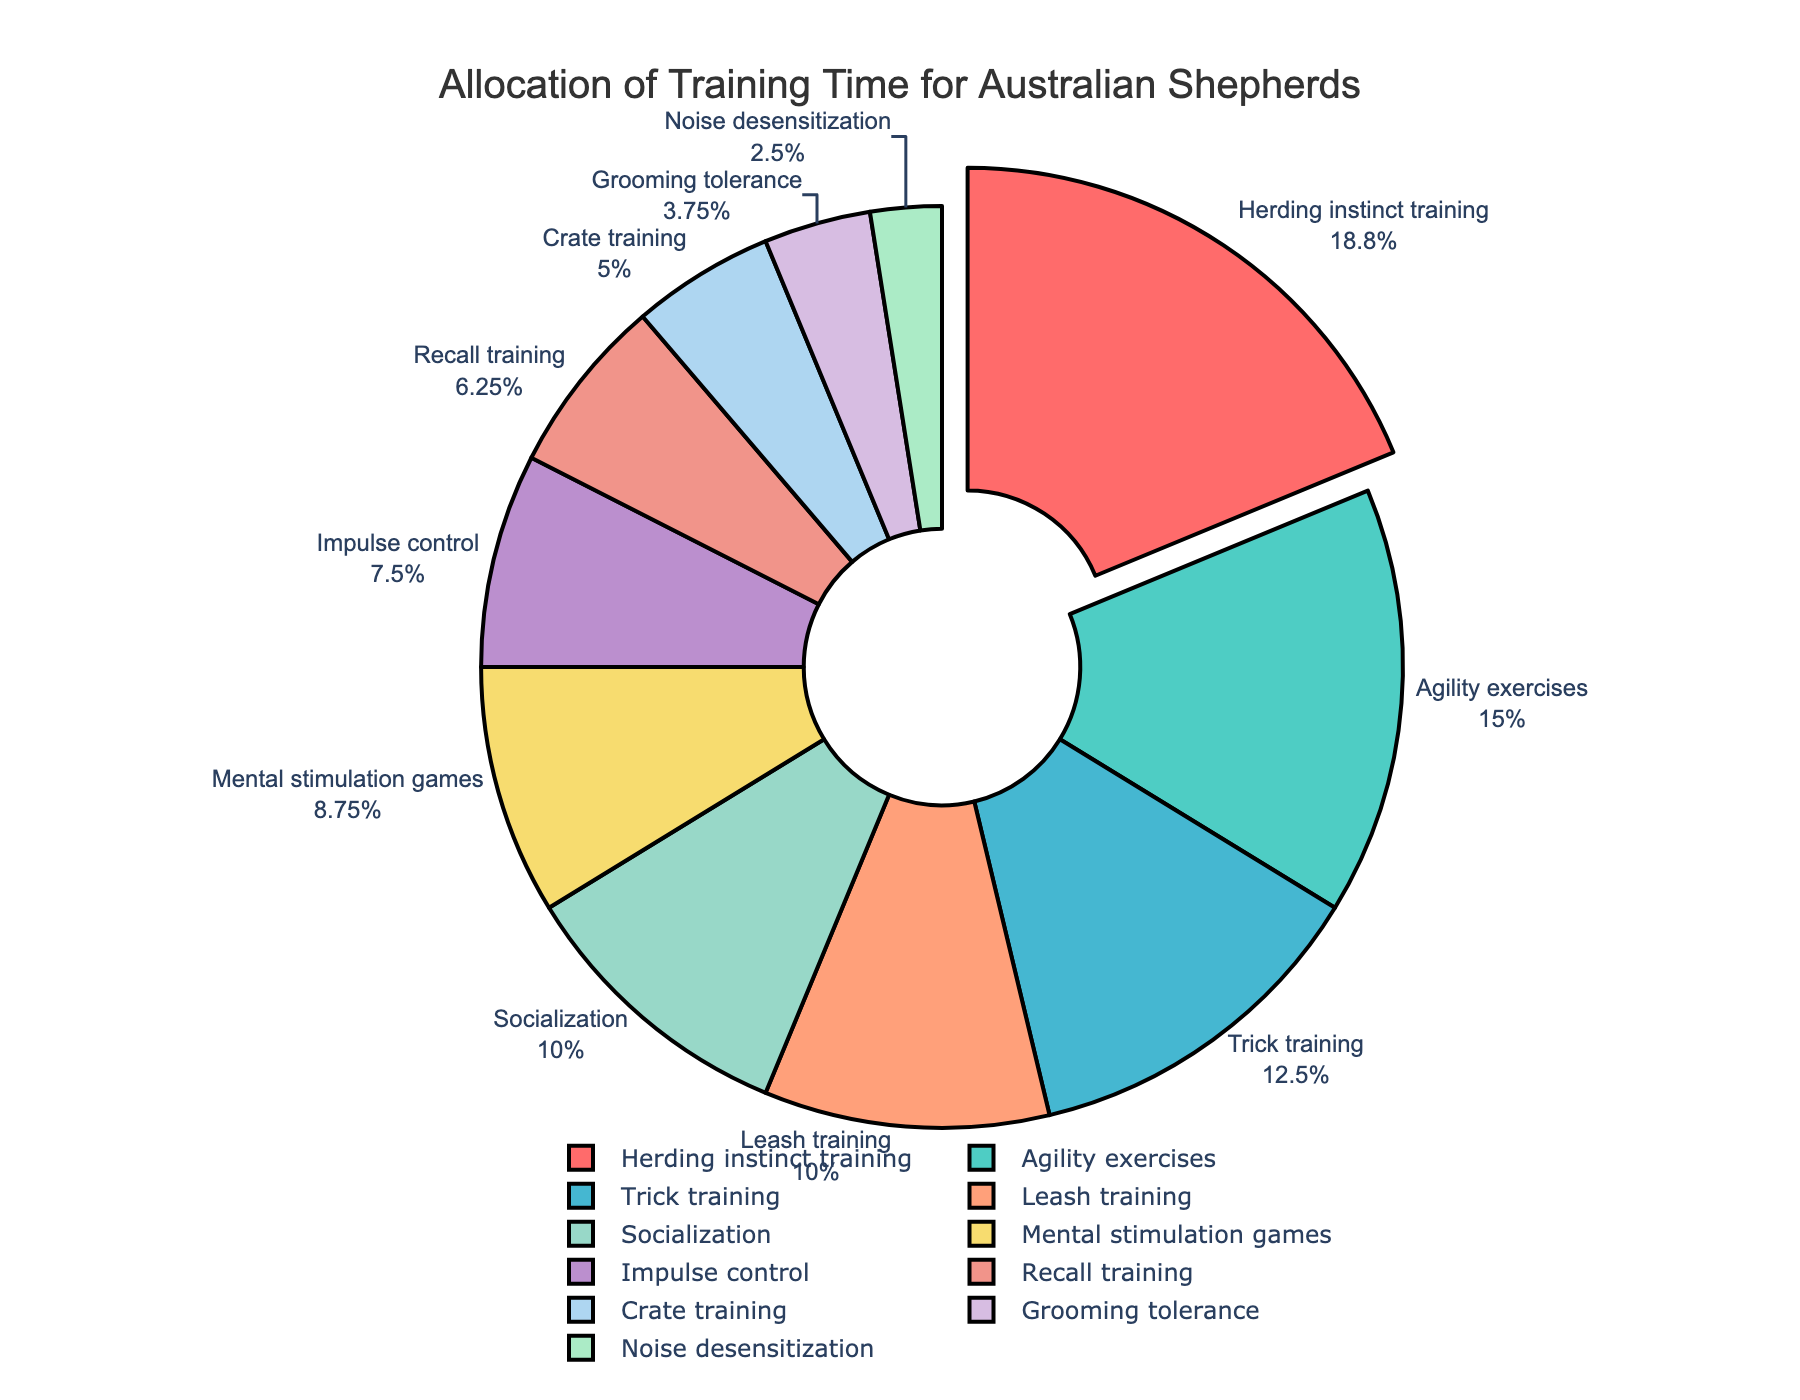What's the largest portion of the pie chart? The largest segment in the pie chart is the one pulled out from the rest, and it's labeled "Herding instinct training" with a percentage of 15%. This is the largest portion.
Answer: Herding instinct training How much time is recommended for trick training relative to leash training? Trick training accounts for 10% of the time, while leash training accounts for 8%. To find how much more time is recommended for trick training relative to leash training, subtract 8% from 10%.
Answer: 2% Which training commands/skills account for less than 5% each in the pie chart? The segments for crate training, grooming tolerance, and noise desensitization are labeled with their percentages: 4%, 3%, and 2%, respectively. All these values are less than 5%.
Answer: Crate training, Grooming tolerance, Noise desensitization What is the combined percentage for mental stimulation games and impulse control? Mental stimulation games are 7% and impulse control is 6%. Adding these together gives 7% + 6% = 13%.
Answer: 13% Which training activity is colored red? In the pie chart, the red-colored segment is "Herding instinct training," which is indicated as the largest segment and is also pulled out from the rest of the pie.
Answer: Herding instinct training Which two training activities have equal recommended times? The pie chart labels show that both leash training and socialization each account for 8% of the training time, indicating that they have equal percentages.
Answer: Leash training and Socialization What percentage of time is recommended for activities related to both physical and mental stimulation combined? Activities related to physical stimulation are herding instinct training (15%) and agility exercises (12%), while mental stimulation includes trick training (10%), mental stimulation games (7%), and impulse control (6%). Adding these together yields 15% + 12% + 10% + 7% + 6% = 50%.
Answer: 50% How much more time is allocated to grooming tolerance than to noise desensitization? Grooming tolerance accounts for 3% and noise desensitization for 2%. The difference is 3% - 2% = 1%.
Answer: 1% Which training activity has the smallest allocation of time? The smallest segment in the pie chart is labeled "Noise desensitization," which is allotted 2% of the training time. This is the smallest allocation.
Answer: Noise desensitization How does the proportion of time for crate training compare to recall training? Crate training is given 4% of the time while recall training is given 5%. To compare, recall training has a higher allocation by 1% (5% - 4%).
Answer: Recall training has 1% more allocation than crate training 